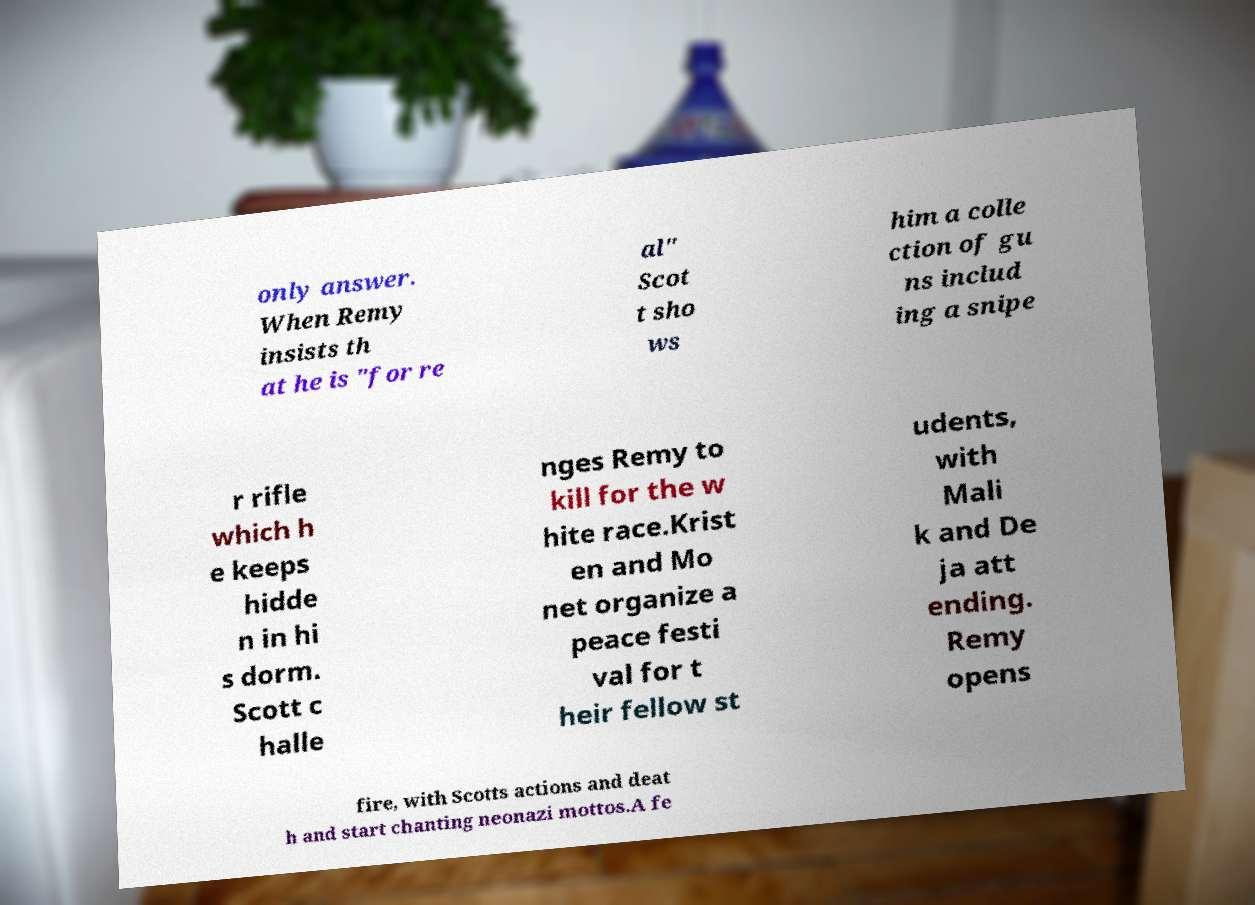What messages or text are displayed in this image? I need them in a readable, typed format. only answer. When Remy insists th at he is "for re al" Scot t sho ws him a colle ction of gu ns includ ing a snipe r rifle which h e keeps hidde n in hi s dorm. Scott c halle nges Remy to kill for the w hite race.Krist en and Mo net organize a peace festi val for t heir fellow st udents, with Mali k and De ja att ending. Remy opens fire, with Scotts actions and deat h and start chanting neonazi mottos.A fe 